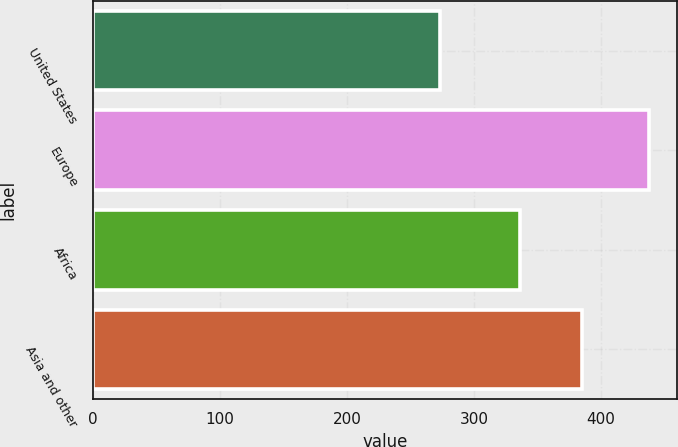Convert chart. <chart><loc_0><loc_0><loc_500><loc_500><bar_chart><fcel>United States<fcel>Europe<fcel>Africa<fcel>Asia and other<nl><fcel>273<fcel>438<fcel>336<fcel>385<nl></chart> 